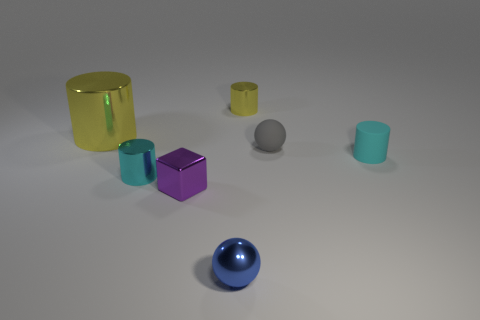Subtract all tiny yellow metal cylinders. How many cylinders are left? 3 Subtract all cyan spheres. How many yellow cylinders are left? 2 Add 1 blue things. How many objects exist? 8 Subtract all blue cylinders. Subtract all brown spheres. How many cylinders are left? 4 Subtract all big yellow rubber spheres. Subtract all yellow cylinders. How many objects are left? 5 Add 5 tiny blue balls. How many tiny blue balls are left? 6 Add 4 tiny blue balls. How many tiny blue balls exist? 5 Subtract 2 cyan cylinders. How many objects are left? 5 Subtract all cylinders. How many objects are left? 3 